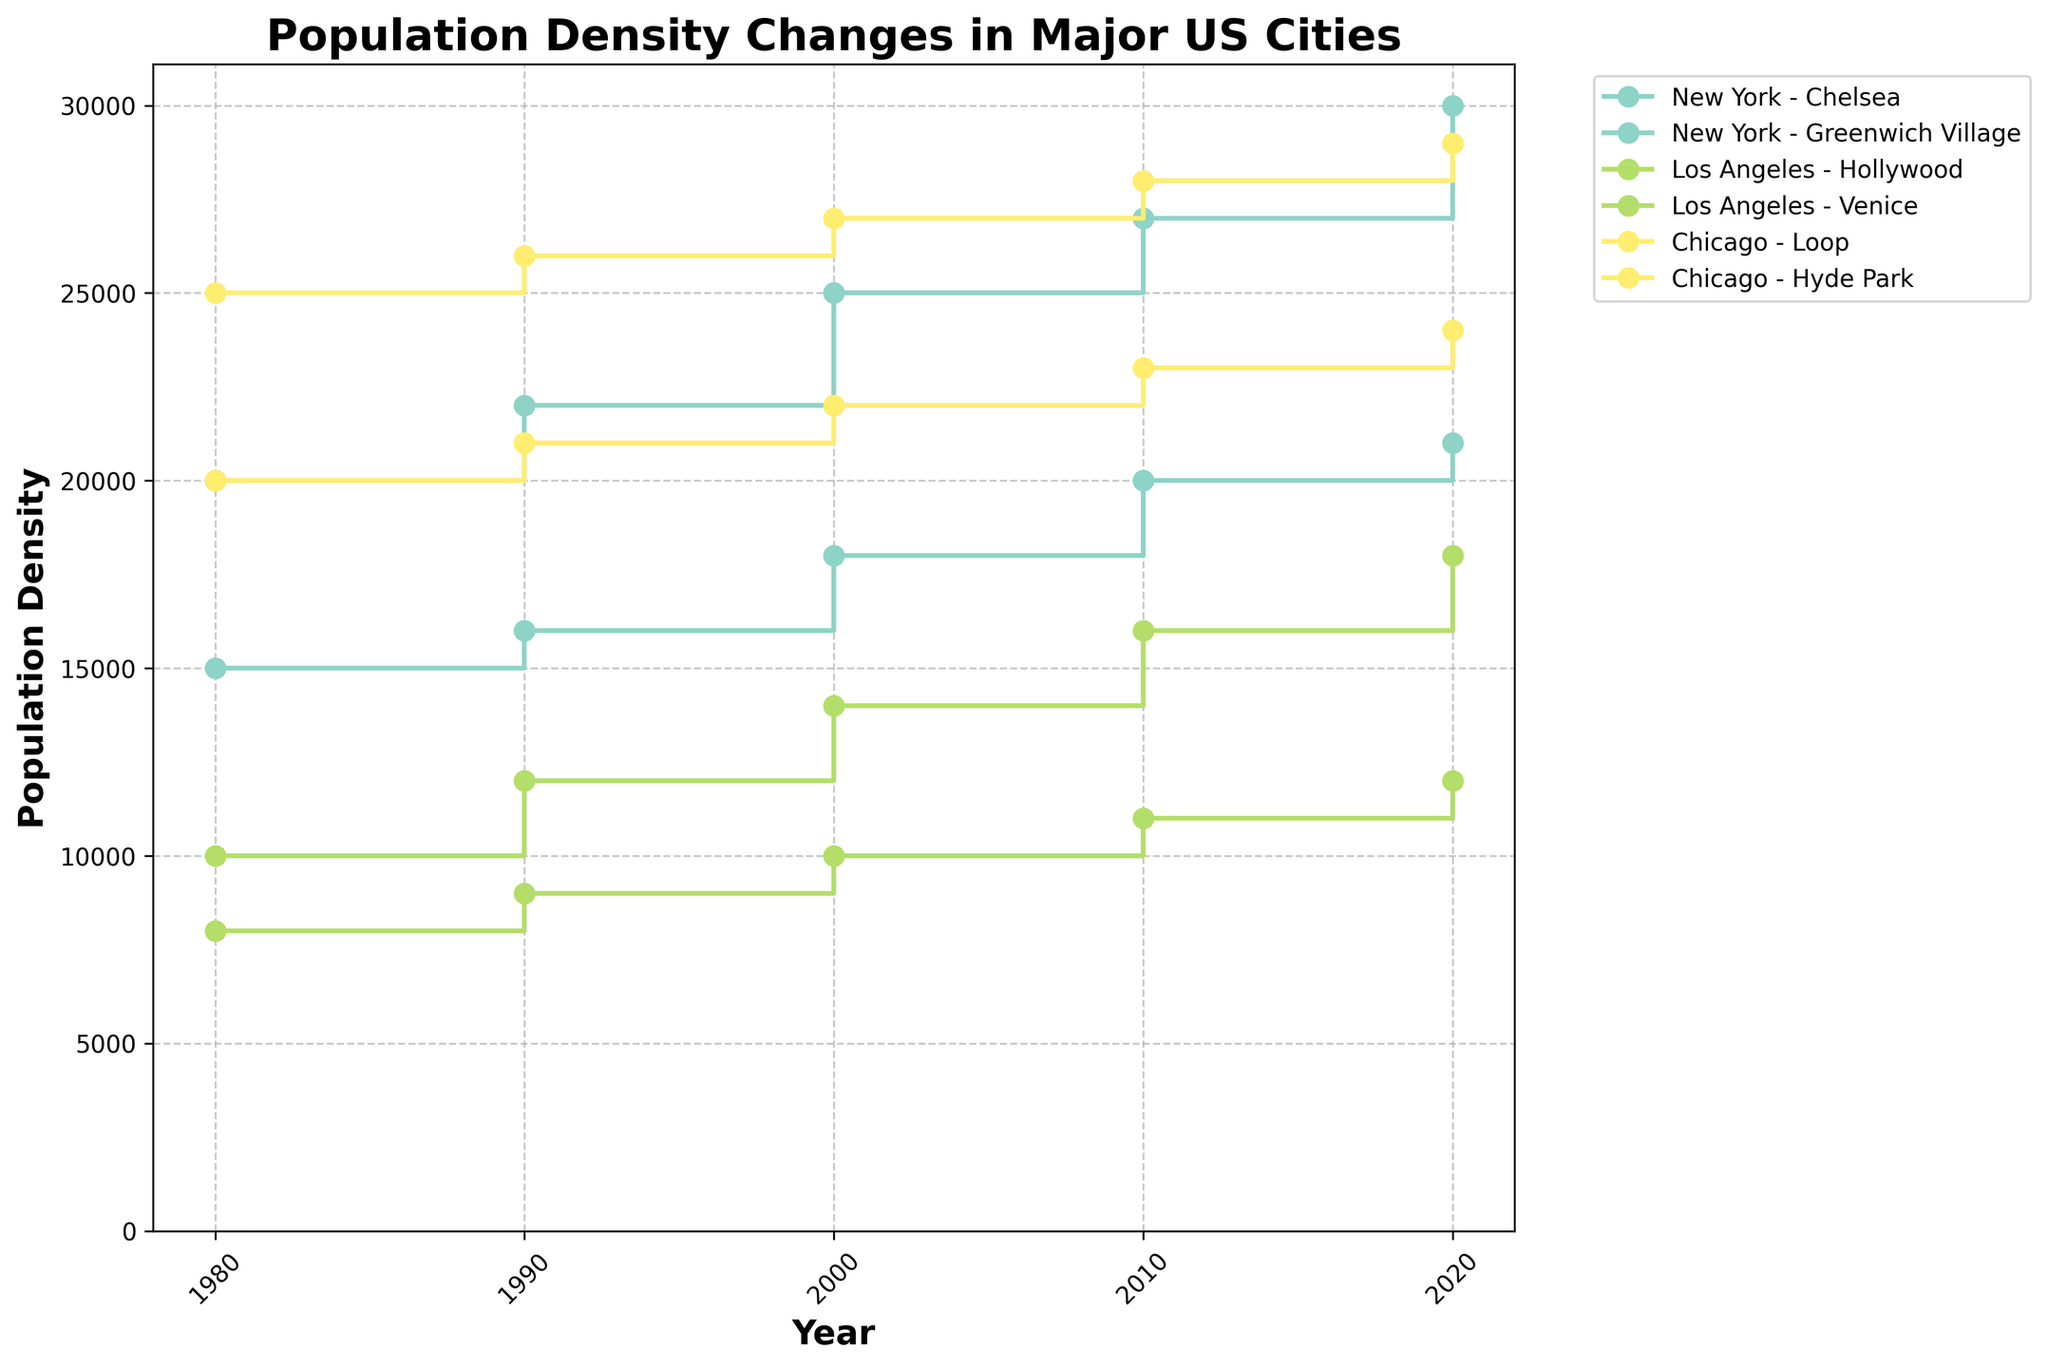What does the title of the figure represent? The title of the figure 'Population Density Changes in Major US Cities' clearly represents the theme, indicating it shows how population density has changed over time in specific neighborhoods of major US cities.
Answer: Population Density Changes in Major US Cities How is the population density in Chicago's Hyde Park in 2020 compared to 1980? In the figure, trace the line for Chicago's Hyde Park from 1980 to 2020 and note the population density values. The 1980 value is 20,000 while the 2020 value is 24,000. Thus, it has increased.
Answer: Increased Which neighborhood in New York showed a consistent increase in population density every decade? Two neighborhoods in New York, Chelsea and Greenwich Village, are shown. Trace their respective lines and observe that the population density has increased every decade. Both neighborhoods showed a consistent increase, so either answer is acceptable.
Answer: Chelsea or Greenwich Village Compare the population densities of Los Angeles' Hollywood and Venice in 2000. Trace the step lines corresponding to Los Angeles' Hollywood and Venice neighborhoods, and note their population densities in 2000. Hollywood is at 14,000 while Venice is at 10,000.
Answer: Hollywood is higher Which city had the neighborhood with the highest population density overall? By visually inspecting all the lines representing different neighborhoods, the highest population density can be identified for Chicago's Loop, which reaches 29,000 in 2020.
Answer: Chicago (Loop) What is the difference in population density between the Loop and Hyde Park neighborhoods in Chicago in 1990? Identify the population densities for both Loop (26,000) and Hyde Park (21,000) in 1990 from the figure. Subtract Hyde Park's density from Loop's density: 26,000 - 21,000 = 5,000.
Answer: 5,000 Between 1980 and 2020, which neighborhood experienced the highest absolute growth in population density? Calculate the absolute growth for each neighborhood by subtracting the 1980 value from the 2020 value: 
- Chelsea: 30,000 - 20,000 = 10,000
- Greenwich Village: 21,000 - 15,000 = 6,000
- Hollywood: 18,000 - 10,000 = 8,000
- Venice: 12,000 - 8,000 = 4,000
- Loop: 29,000 - 25,000 = 4,000
- Hyde Park: 24,000 - 20,000 = 4,000
The highest absolute growth is Chelsea with 10,000.
Answer: Chelsea Did any neighborhood in Los Angeles have a reduction in population density in any decade? By analyzing the lines for both Hollywood and Venice, observe that none of the lines drop in any decade. Both neighborhoods show a steady increase over each decade.
Answer: No What is the average population density of New York's Chelsea across the decades shown? Sum the population densities of Chelsea for each decade and divide by the number of data points: (20,000 + 22,000 + 25,000 + 27,000 + 30,000) / 5 = 124,000 / 5 = 24,800.
Answer: 24,800 In which decade did Hollywood see the largest increase in population density? Observe the increments between the steps in Hollywood’s line:
- 1980 to 1990: 12,000 - 10,000 = 2,000
- 1990 to 2000: 14,000 - 12,000 = 2,000
- 2000 to 2010: 16,000 - 14,000 = 2,000
- 2010 to 2020: 18,000 - 16,000 = 2,000
Each decade has equivalent growth of 2,000 in Hollywood, thus no decade shows a larger increase than another.
Answer: No decade 